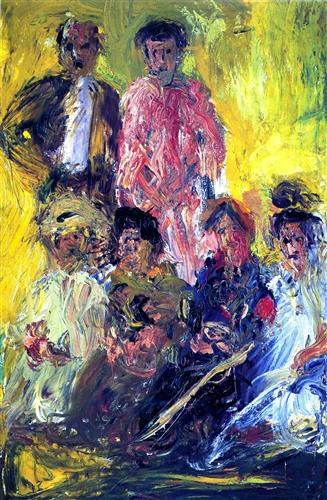Can you infer anything about the setting of this scene? While specifics about the setting are open to interpretation, the arrangement of figures suggests an indoor gathering. The warmth of the colors and casual postures of the figures might imply a familiar, intimate space such as a parlor or salon, where individuals have come together for conversation and leisure. 